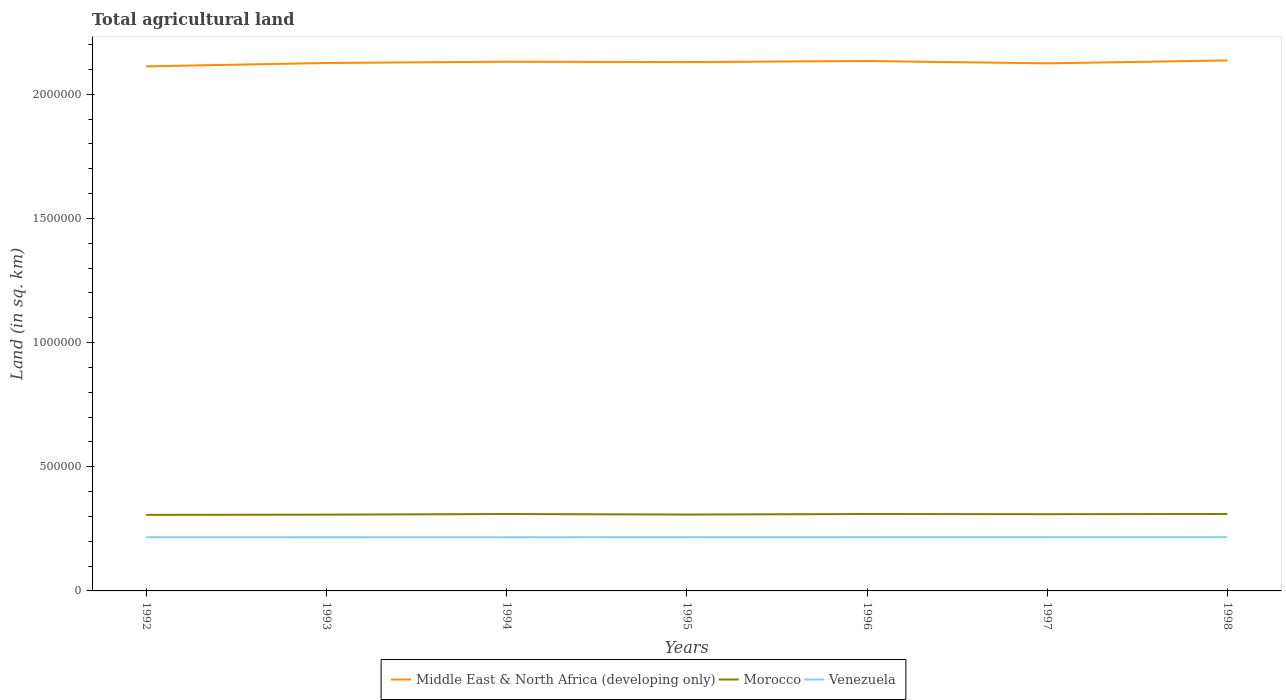How many different coloured lines are there?
Your response must be concise. 3. Across all years, what is the maximum total agricultural land in Venezuela?
Ensure brevity in your answer.  2.16e+05. What is the total total agricultural land in Morocco in the graph?
Give a very brief answer. -3600. What is the difference between the highest and the second highest total agricultural land in Venezuela?
Make the answer very short. 390. Does the graph contain any zero values?
Your answer should be compact. No. Does the graph contain grids?
Ensure brevity in your answer.  No. Where does the legend appear in the graph?
Give a very brief answer. Bottom center. What is the title of the graph?
Provide a succinct answer. Total agricultural land. What is the label or title of the X-axis?
Provide a succinct answer. Years. What is the label or title of the Y-axis?
Give a very brief answer. Land (in sq. km). What is the Land (in sq. km) in Middle East & North Africa (developing only) in 1992?
Provide a succinct answer. 2.11e+06. What is the Land (in sq. km) of Morocco in 1992?
Keep it short and to the point. 3.06e+05. What is the Land (in sq. km) in Venezuela in 1992?
Your answer should be very brief. 2.16e+05. What is the Land (in sq. km) in Middle East & North Africa (developing only) in 1993?
Offer a terse response. 2.13e+06. What is the Land (in sq. km) in Morocco in 1993?
Your response must be concise. 3.07e+05. What is the Land (in sq. km) in Venezuela in 1993?
Your answer should be compact. 2.16e+05. What is the Land (in sq. km) in Middle East & North Africa (developing only) in 1994?
Offer a very short reply. 2.13e+06. What is the Land (in sq. km) of Morocco in 1994?
Your answer should be very brief. 3.10e+05. What is the Land (in sq. km) of Venezuela in 1994?
Keep it short and to the point. 2.16e+05. What is the Land (in sq. km) in Middle East & North Africa (developing only) in 1995?
Give a very brief answer. 2.13e+06. What is the Land (in sq. km) in Morocco in 1995?
Your response must be concise. 3.07e+05. What is the Land (in sq. km) of Venezuela in 1995?
Offer a very short reply. 2.16e+05. What is the Land (in sq. km) in Middle East & North Africa (developing only) in 1996?
Your answer should be compact. 2.13e+06. What is the Land (in sq. km) in Morocco in 1996?
Your response must be concise. 3.10e+05. What is the Land (in sq. km) of Venezuela in 1996?
Make the answer very short. 2.16e+05. What is the Land (in sq. km) in Middle East & North Africa (developing only) in 1997?
Your answer should be compact. 2.12e+06. What is the Land (in sq. km) in Morocco in 1997?
Provide a short and direct response. 3.09e+05. What is the Land (in sq. km) in Venezuela in 1997?
Your response must be concise. 2.16e+05. What is the Land (in sq. km) of Middle East & North Africa (developing only) in 1998?
Make the answer very short. 2.14e+06. What is the Land (in sq. km) in Morocco in 1998?
Ensure brevity in your answer.  3.10e+05. What is the Land (in sq. km) of Venezuela in 1998?
Provide a short and direct response. 2.16e+05. Across all years, what is the maximum Land (in sq. km) of Middle East & North Africa (developing only)?
Provide a succinct answer. 2.14e+06. Across all years, what is the maximum Land (in sq. km) in Morocco?
Keep it short and to the point. 3.10e+05. Across all years, what is the maximum Land (in sq. km) of Venezuela?
Give a very brief answer. 2.16e+05. Across all years, what is the minimum Land (in sq. km) in Middle East & North Africa (developing only)?
Your answer should be very brief. 2.11e+06. Across all years, what is the minimum Land (in sq. km) in Morocco?
Keep it short and to the point. 3.06e+05. Across all years, what is the minimum Land (in sq. km) in Venezuela?
Provide a short and direct response. 2.16e+05. What is the total Land (in sq. km) of Middle East & North Africa (developing only) in the graph?
Provide a short and direct response. 1.49e+07. What is the total Land (in sq. km) of Morocco in the graph?
Offer a very short reply. 2.16e+06. What is the total Land (in sq. km) of Venezuela in the graph?
Your answer should be compact. 1.51e+06. What is the difference between the Land (in sq. km) of Middle East & North Africa (developing only) in 1992 and that in 1993?
Offer a very short reply. -1.37e+04. What is the difference between the Land (in sq. km) in Morocco in 1992 and that in 1993?
Your answer should be compact. -950. What is the difference between the Land (in sq. km) of Middle East & North Africa (developing only) in 1992 and that in 1994?
Provide a succinct answer. -1.89e+04. What is the difference between the Land (in sq. km) in Morocco in 1992 and that in 1994?
Offer a very short reply. -3480. What is the difference between the Land (in sq. km) of Middle East & North Africa (developing only) in 1992 and that in 1995?
Provide a short and direct response. -1.73e+04. What is the difference between the Land (in sq. km) of Morocco in 1992 and that in 1995?
Offer a terse response. -1330. What is the difference between the Land (in sq. km) in Venezuela in 1992 and that in 1995?
Keep it short and to the point. -130. What is the difference between the Land (in sq. km) of Middle East & North Africa (developing only) in 1992 and that in 1996?
Ensure brevity in your answer.  -2.17e+04. What is the difference between the Land (in sq. km) in Morocco in 1992 and that in 1996?
Ensure brevity in your answer.  -3500. What is the difference between the Land (in sq. km) of Venezuela in 1992 and that in 1996?
Ensure brevity in your answer.  -250. What is the difference between the Land (in sq. km) of Middle East & North Africa (developing only) in 1992 and that in 1997?
Your answer should be very brief. -1.22e+04. What is the difference between the Land (in sq. km) in Morocco in 1992 and that in 1997?
Give a very brief answer. -2790. What is the difference between the Land (in sq. km) of Venezuela in 1992 and that in 1997?
Offer a very short reply. -290. What is the difference between the Land (in sq. km) in Middle East & North Africa (developing only) in 1992 and that in 1998?
Provide a short and direct response. -2.40e+04. What is the difference between the Land (in sq. km) in Morocco in 1992 and that in 1998?
Give a very brief answer. -3600. What is the difference between the Land (in sq. km) in Venezuela in 1992 and that in 1998?
Ensure brevity in your answer.  -350. What is the difference between the Land (in sq. km) in Middle East & North Africa (developing only) in 1993 and that in 1994?
Offer a terse response. -5190. What is the difference between the Land (in sq. km) in Morocco in 1993 and that in 1994?
Provide a succinct answer. -2530. What is the difference between the Land (in sq. km) in Venezuela in 1993 and that in 1994?
Offer a terse response. -70. What is the difference between the Land (in sq. km) of Middle East & North Africa (developing only) in 1993 and that in 1995?
Ensure brevity in your answer.  -3650. What is the difference between the Land (in sq. km) in Morocco in 1993 and that in 1995?
Make the answer very short. -380. What is the difference between the Land (in sq. km) of Venezuela in 1993 and that in 1995?
Your answer should be very brief. -170. What is the difference between the Land (in sq. km) in Middle East & North Africa (developing only) in 1993 and that in 1996?
Provide a succinct answer. -8004.6. What is the difference between the Land (in sq. km) of Morocco in 1993 and that in 1996?
Offer a terse response. -2550. What is the difference between the Land (in sq. km) of Venezuela in 1993 and that in 1996?
Provide a succinct answer. -290. What is the difference between the Land (in sq. km) in Middle East & North Africa (developing only) in 1993 and that in 1997?
Provide a succinct answer. 1490.8. What is the difference between the Land (in sq. km) of Morocco in 1993 and that in 1997?
Your response must be concise. -1840. What is the difference between the Land (in sq. km) in Venezuela in 1993 and that in 1997?
Your answer should be very brief. -330. What is the difference between the Land (in sq. km) of Middle East & North Africa (developing only) in 1993 and that in 1998?
Your response must be concise. -1.03e+04. What is the difference between the Land (in sq. km) in Morocco in 1993 and that in 1998?
Ensure brevity in your answer.  -2650. What is the difference between the Land (in sq. km) in Venezuela in 1993 and that in 1998?
Provide a short and direct response. -390. What is the difference between the Land (in sq. km) in Middle East & North Africa (developing only) in 1994 and that in 1995?
Give a very brief answer. 1540. What is the difference between the Land (in sq. km) in Morocco in 1994 and that in 1995?
Your answer should be compact. 2150. What is the difference between the Land (in sq. km) in Venezuela in 1994 and that in 1995?
Offer a very short reply. -100. What is the difference between the Land (in sq. km) in Middle East & North Africa (developing only) in 1994 and that in 1996?
Make the answer very short. -2814.6. What is the difference between the Land (in sq. km) of Morocco in 1994 and that in 1996?
Provide a short and direct response. -20. What is the difference between the Land (in sq. km) in Venezuela in 1994 and that in 1996?
Provide a short and direct response. -220. What is the difference between the Land (in sq. km) in Middle East & North Africa (developing only) in 1994 and that in 1997?
Your answer should be compact. 6680.8. What is the difference between the Land (in sq. km) in Morocco in 1994 and that in 1997?
Offer a terse response. 690. What is the difference between the Land (in sq. km) of Venezuela in 1994 and that in 1997?
Make the answer very short. -260. What is the difference between the Land (in sq. km) in Middle East & North Africa (developing only) in 1994 and that in 1998?
Your answer should be compact. -5136.2. What is the difference between the Land (in sq. km) of Morocco in 1994 and that in 1998?
Give a very brief answer. -120. What is the difference between the Land (in sq. km) in Venezuela in 1994 and that in 1998?
Offer a terse response. -320. What is the difference between the Land (in sq. km) in Middle East & North Africa (developing only) in 1995 and that in 1996?
Offer a terse response. -4354.6. What is the difference between the Land (in sq. km) in Morocco in 1995 and that in 1996?
Offer a terse response. -2170. What is the difference between the Land (in sq. km) in Venezuela in 1995 and that in 1996?
Provide a succinct answer. -120. What is the difference between the Land (in sq. km) of Middle East & North Africa (developing only) in 1995 and that in 1997?
Offer a very short reply. 5140.8. What is the difference between the Land (in sq. km) of Morocco in 1995 and that in 1997?
Provide a short and direct response. -1460. What is the difference between the Land (in sq. km) in Venezuela in 1995 and that in 1997?
Offer a very short reply. -160. What is the difference between the Land (in sq. km) of Middle East & North Africa (developing only) in 1995 and that in 1998?
Keep it short and to the point. -6676.2. What is the difference between the Land (in sq. km) in Morocco in 1995 and that in 1998?
Offer a very short reply. -2270. What is the difference between the Land (in sq. km) in Venezuela in 1995 and that in 1998?
Your answer should be very brief. -220. What is the difference between the Land (in sq. km) in Middle East & North Africa (developing only) in 1996 and that in 1997?
Your answer should be very brief. 9495.4. What is the difference between the Land (in sq. km) in Morocco in 1996 and that in 1997?
Give a very brief answer. 710. What is the difference between the Land (in sq. km) of Venezuela in 1996 and that in 1997?
Your answer should be compact. -40. What is the difference between the Land (in sq. km) in Middle East & North Africa (developing only) in 1996 and that in 1998?
Ensure brevity in your answer.  -2321.6. What is the difference between the Land (in sq. km) in Morocco in 1996 and that in 1998?
Offer a very short reply. -100. What is the difference between the Land (in sq. km) of Venezuela in 1996 and that in 1998?
Offer a very short reply. -100. What is the difference between the Land (in sq. km) in Middle East & North Africa (developing only) in 1997 and that in 1998?
Your answer should be compact. -1.18e+04. What is the difference between the Land (in sq. km) of Morocco in 1997 and that in 1998?
Ensure brevity in your answer.  -810. What is the difference between the Land (in sq. km) in Venezuela in 1997 and that in 1998?
Keep it short and to the point. -60. What is the difference between the Land (in sq. km) of Middle East & North Africa (developing only) in 1992 and the Land (in sq. km) of Morocco in 1993?
Provide a succinct answer. 1.80e+06. What is the difference between the Land (in sq. km) in Middle East & North Africa (developing only) in 1992 and the Land (in sq. km) in Venezuela in 1993?
Keep it short and to the point. 1.90e+06. What is the difference between the Land (in sq. km) of Morocco in 1992 and the Land (in sq. km) of Venezuela in 1993?
Your answer should be compact. 9.01e+04. What is the difference between the Land (in sq. km) of Middle East & North Africa (developing only) in 1992 and the Land (in sq. km) of Morocco in 1994?
Your answer should be very brief. 1.80e+06. What is the difference between the Land (in sq. km) of Middle East & North Africa (developing only) in 1992 and the Land (in sq. km) of Venezuela in 1994?
Make the answer very short. 1.90e+06. What is the difference between the Land (in sq. km) in Morocco in 1992 and the Land (in sq. km) in Venezuela in 1994?
Make the answer very short. 9.01e+04. What is the difference between the Land (in sq. km) of Middle East & North Africa (developing only) in 1992 and the Land (in sq. km) of Morocco in 1995?
Give a very brief answer. 1.80e+06. What is the difference between the Land (in sq. km) in Middle East & North Africa (developing only) in 1992 and the Land (in sq. km) in Venezuela in 1995?
Offer a very short reply. 1.90e+06. What is the difference between the Land (in sq. km) in Morocco in 1992 and the Land (in sq. km) in Venezuela in 1995?
Ensure brevity in your answer.  9.00e+04. What is the difference between the Land (in sq. km) of Middle East & North Africa (developing only) in 1992 and the Land (in sq. km) of Morocco in 1996?
Your answer should be compact. 1.80e+06. What is the difference between the Land (in sq. km) of Middle East & North Africa (developing only) in 1992 and the Land (in sq. km) of Venezuela in 1996?
Provide a short and direct response. 1.90e+06. What is the difference between the Land (in sq. km) of Morocco in 1992 and the Land (in sq. km) of Venezuela in 1996?
Provide a succinct answer. 8.98e+04. What is the difference between the Land (in sq. km) in Middle East & North Africa (developing only) in 1992 and the Land (in sq. km) in Morocco in 1997?
Provide a succinct answer. 1.80e+06. What is the difference between the Land (in sq. km) of Middle East & North Africa (developing only) in 1992 and the Land (in sq. km) of Venezuela in 1997?
Provide a short and direct response. 1.90e+06. What is the difference between the Land (in sq. km) of Morocco in 1992 and the Land (in sq. km) of Venezuela in 1997?
Your answer should be compact. 8.98e+04. What is the difference between the Land (in sq. km) of Middle East & North Africa (developing only) in 1992 and the Land (in sq. km) of Morocco in 1998?
Give a very brief answer. 1.80e+06. What is the difference between the Land (in sq. km) of Middle East & North Africa (developing only) in 1992 and the Land (in sq. km) of Venezuela in 1998?
Keep it short and to the point. 1.90e+06. What is the difference between the Land (in sq. km) of Morocco in 1992 and the Land (in sq. km) of Venezuela in 1998?
Your answer should be compact. 8.97e+04. What is the difference between the Land (in sq. km) of Middle East & North Africa (developing only) in 1993 and the Land (in sq. km) of Morocco in 1994?
Your answer should be compact. 1.82e+06. What is the difference between the Land (in sq. km) in Middle East & North Africa (developing only) in 1993 and the Land (in sq. km) in Venezuela in 1994?
Provide a short and direct response. 1.91e+06. What is the difference between the Land (in sq. km) of Morocco in 1993 and the Land (in sq. km) of Venezuela in 1994?
Offer a very short reply. 9.10e+04. What is the difference between the Land (in sq. km) in Middle East & North Africa (developing only) in 1993 and the Land (in sq. km) in Morocco in 1995?
Give a very brief answer. 1.82e+06. What is the difference between the Land (in sq. km) of Middle East & North Africa (developing only) in 1993 and the Land (in sq. km) of Venezuela in 1995?
Your answer should be very brief. 1.91e+06. What is the difference between the Land (in sq. km) in Morocco in 1993 and the Land (in sq. km) in Venezuela in 1995?
Provide a succinct answer. 9.09e+04. What is the difference between the Land (in sq. km) in Middle East & North Africa (developing only) in 1993 and the Land (in sq. km) in Morocco in 1996?
Keep it short and to the point. 1.82e+06. What is the difference between the Land (in sq. km) of Middle East & North Africa (developing only) in 1993 and the Land (in sq. km) of Venezuela in 1996?
Your response must be concise. 1.91e+06. What is the difference between the Land (in sq. km) of Morocco in 1993 and the Land (in sq. km) of Venezuela in 1996?
Ensure brevity in your answer.  9.08e+04. What is the difference between the Land (in sq. km) of Middle East & North Africa (developing only) in 1993 and the Land (in sq. km) of Morocco in 1997?
Keep it short and to the point. 1.82e+06. What is the difference between the Land (in sq. km) in Middle East & North Africa (developing only) in 1993 and the Land (in sq. km) in Venezuela in 1997?
Your answer should be compact. 1.91e+06. What is the difference between the Land (in sq. km) of Morocco in 1993 and the Land (in sq. km) of Venezuela in 1997?
Your answer should be compact. 9.08e+04. What is the difference between the Land (in sq. km) of Middle East & North Africa (developing only) in 1993 and the Land (in sq. km) of Morocco in 1998?
Your response must be concise. 1.82e+06. What is the difference between the Land (in sq. km) in Middle East & North Africa (developing only) in 1993 and the Land (in sq. km) in Venezuela in 1998?
Give a very brief answer. 1.91e+06. What is the difference between the Land (in sq. km) of Morocco in 1993 and the Land (in sq. km) of Venezuela in 1998?
Your answer should be compact. 9.07e+04. What is the difference between the Land (in sq. km) of Middle East & North Africa (developing only) in 1994 and the Land (in sq. km) of Morocco in 1995?
Offer a very short reply. 1.82e+06. What is the difference between the Land (in sq. km) in Middle East & North Africa (developing only) in 1994 and the Land (in sq. km) in Venezuela in 1995?
Give a very brief answer. 1.91e+06. What is the difference between the Land (in sq. km) of Morocco in 1994 and the Land (in sq. km) of Venezuela in 1995?
Offer a very short reply. 9.34e+04. What is the difference between the Land (in sq. km) in Middle East & North Africa (developing only) in 1994 and the Land (in sq. km) in Morocco in 1996?
Give a very brief answer. 1.82e+06. What is the difference between the Land (in sq. km) of Middle East & North Africa (developing only) in 1994 and the Land (in sq. km) of Venezuela in 1996?
Your answer should be very brief. 1.91e+06. What is the difference between the Land (in sq. km) in Morocco in 1994 and the Land (in sq. km) in Venezuela in 1996?
Your answer should be very brief. 9.33e+04. What is the difference between the Land (in sq. km) of Middle East & North Africa (developing only) in 1994 and the Land (in sq. km) of Morocco in 1997?
Provide a short and direct response. 1.82e+06. What is the difference between the Land (in sq. km) of Middle East & North Africa (developing only) in 1994 and the Land (in sq. km) of Venezuela in 1997?
Ensure brevity in your answer.  1.91e+06. What is the difference between the Land (in sq. km) of Morocco in 1994 and the Land (in sq. km) of Venezuela in 1997?
Keep it short and to the point. 9.33e+04. What is the difference between the Land (in sq. km) in Middle East & North Africa (developing only) in 1994 and the Land (in sq. km) in Morocco in 1998?
Make the answer very short. 1.82e+06. What is the difference between the Land (in sq. km) in Middle East & North Africa (developing only) in 1994 and the Land (in sq. km) in Venezuela in 1998?
Give a very brief answer. 1.91e+06. What is the difference between the Land (in sq. km) in Morocco in 1994 and the Land (in sq. km) in Venezuela in 1998?
Your answer should be compact. 9.32e+04. What is the difference between the Land (in sq. km) of Middle East & North Africa (developing only) in 1995 and the Land (in sq. km) of Morocco in 1996?
Your answer should be very brief. 1.82e+06. What is the difference between the Land (in sq. km) of Middle East & North Africa (developing only) in 1995 and the Land (in sq. km) of Venezuela in 1996?
Keep it short and to the point. 1.91e+06. What is the difference between the Land (in sq. km) of Morocco in 1995 and the Land (in sq. km) of Venezuela in 1996?
Ensure brevity in your answer.  9.12e+04. What is the difference between the Land (in sq. km) of Middle East & North Africa (developing only) in 1995 and the Land (in sq. km) of Morocco in 1997?
Give a very brief answer. 1.82e+06. What is the difference between the Land (in sq. km) of Middle East & North Africa (developing only) in 1995 and the Land (in sq. km) of Venezuela in 1997?
Make the answer very short. 1.91e+06. What is the difference between the Land (in sq. km) of Morocco in 1995 and the Land (in sq. km) of Venezuela in 1997?
Your answer should be very brief. 9.11e+04. What is the difference between the Land (in sq. km) in Middle East & North Africa (developing only) in 1995 and the Land (in sq. km) in Morocco in 1998?
Your response must be concise. 1.82e+06. What is the difference between the Land (in sq. km) of Middle East & North Africa (developing only) in 1995 and the Land (in sq. km) of Venezuela in 1998?
Provide a short and direct response. 1.91e+06. What is the difference between the Land (in sq. km) in Morocco in 1995 and the Land (in sq. km) in Venezuela in 1998?
Keep it short and to the point. 9.11e+04. What is the difference between the Land (in sq. km) in Middle East & North Africa (developing only) in 1996 and the Land (in sq. km) in Morocco in 1997?
Make the answer very short. 1.82e+06. What is the difference between the Land (in sq. km) of Middle East & North Africa (developing only) in 1996 and the Land (in sq. km) of Venezuela in 1997?
Provide a short and direct response. 1.92e+06. What is the difference between the Land (in sq. km) in Morocco in 1996 and the Land (in sq. km) in Venezuela in 1997?
Ensure brevity in your answer.  9.33e+04. What is the difference between the Land (in sq. km) of Middle East & North Africa (developing only) in 1996 and the Land (in sq. km) of Morocco in 1998?
Give a very brief answer. 1.82e+06. What is the difference between the Land (in sq. km) in Middle East & North Africa (developing only) in 1996 and the Land (in sq. km) in Venezuela in 1998?
Give a very brief answer. 1.92e+06. What is the difference between the Land (in sq. km) of Morocco in 1996 and the Land (in sq. km) of Venezuela in 1998?
Your answer should be compact. 9.32e+04. What is the difference between the Land (in sq. km) of Middle East & North Africa (developing only) in 1997 and the Land (in sq. km) of Morocco in 1998?
Your answer should be compact. 1.81e+06. What is the difference between the Land (in sq. km) in Middle East & North Africa (developing only) in 1997 and the Land (in sq. km) in Venezuela in 1998?
Give a very brief answer. 1.91e+06. What is the difference between the Land (in sq. km) of Morocco in 1997 and the Land (in sq. km) of Venezuela in 1998?
Provide a succinct answer. 9.25e+04. What is the average Land (in sq. km) of Middle East & North Africa (developing only) per year?
Ensure brevity in your answer.  2.13e+06. What is the average Land (in sq. km) in Morocco per year?
Provide a succinct answer. 3.08e+05. What is the average Land (in sq. km) of Venezuela per year?
Your answer should be very brief. 2.16e+05. In the year 1992, what is the difference between the Land (in sq. km) in Middle East & North Africa (developing only) and Land (in sq. km) in Morocco?
Ensure brevity in your answer.  1.81e+06. In the year 1992, what is the difference between the Land (in sq. km) of Middle East & North Africa (developing only) and Land (in sq. km) of Venezuela?
Make the answer very short. 1.90e+06. In the year 1992, what is the difference between the Land (in sq. km) in Morocco and Land (in sq. km) in Venezuela?
Provide a short and direct response. 9.01e+04. In the year 1993, what is the difference between the Land (in sq. km) of Middle East & North Africa (developing only) and Land (in sq. km) of Morocco?
Give a very brief answer. 1.82e+06. In the year 1993, what is the difference between the Land (in sq. km) in Middle East & North Africa (developing only) and Land (in sq. km) in Venezuela?
Your answer should be very brief. 1.91e+06. In the year 1993, what is the difference between the Land (in sq. km) of Morocco and Land (in sq. km) of Venezuela?
Offer a terse response. 9.11e+04. In the year 1994, what is the difference between the Land (in sq. km) of Middle East & North Africa (developing only) and Land (in sq. km) of Morocco?
Offer a terse response. 1.82e+06. In the year 1994, what is the difference between the Land (in sq. km) in Middle East & North Africa (developing only) and Land (in sq. km) in Venezuela?
Keep it short and to the point. 1.91e+06. In the year 1994, what is the difference between the Land (in sq. km) in Morocco and Land (in sq. km) in Venezuela?
Provide a succinct answer. 9.35e+04. In the year 1995, what is the difference between the Land (in sq. km) in Middle East & North Africa (developing only) and Land (in sq. km) in Morocco?
Offer a very short reply. 1.82e+06. In the year 1995, what is the difference between the Land (in sq. km) in Middle East & North Africa (developing only) and Land (in sq. km) in Venezuela?
Your response must be concise. 1.91e+06. In the year 1995, what is the difference between the Land (in sq. km) in Morocco and Land (in sq. km) in Venezuela?
Give a very brief answer. 9.13e+04. In the year 1996, what is the difference between the Land (in sq. km) of Middle East & North Africa (developing only) and Land (in sq. km) of Morocco?
Your response must be concise. 1.82e+06. In the year 1996, what is the difference between the Land (in sq. km) in Middle East & North Africa (developing only) and Land (in sq. km) in Venezuela?
Offer a terse response. 1.92e+06. In the year 1996, what is the difference between the Land (in sq. km) in Morocco and Land (in sq. km) in Venezuela?
Provide a short and direct response. 9.33e+04. In the year 1997, what is the difference between the Land (in sq. km) of Middle East & North Africa (developing only) and Land (in sq. km) of Morocco?
Your answer should be very brief. 1.82e+06. In the year 1997, what is the difference between the Land (in sq. km) of Middle East & North Africa (developing only) and Land (in sq. km) of Venezuela?
Offer a terse response. 1.91e+06. In the year 1997, what is the difference between the Land (in sq. km) in Morocco and Land (in sq. km) in Venezuela?
Provide a short and direct response. 9.26e+04. In the year 1998, what is the difference between the Land (in sq. km) of Middle East & North Africa (developing only) and Land (in sq. km) of Morocco?
Offer a very short reply. 1.83e+06. In the year 1998, what is the difference between the Land (in sq. km) of Middle East & North Africa (developing only) and Land (in sq. km) of Venezuela?
Ensure brevity in your answer.  1.92e+06. In the year 1998, what is the difference between the Land (in sq. km) of Morocco and Land (in sq. km) of Venezuela?
Offer a very short reply. 9.33e+04. What is the ratio of the Land (in sq. km) of Middle East & North Africa (developing only) in 1992 to that in 1993?
Your answer should be very brief. 0.99. What is the ratio of the Land (in sq. km) in Morocco in 1992 to that in 1993?
Provide a short and direct response. 1. What is the ratio of the Land (in sq. km) in Venezuela in 1992 to that in 1993?
Provide a succinct answer. 1. What is the ratio of the Land (in sq. km) of Middle East & North Africa (developing only) in 1992 to that in 1994?
Ensure brevity in your answer.  0.99. What is the ratio of the Land (in sq. km) in Morocco in 1992 to that in 1994?
Offer a very short reply. 0.99. What is the ratio of the Land (in sq. km) in Middle East & North Africa (developing only) in 1992 to that in 1995?
Offer a very short reply. 0.99. What is the ratio of the Land (in sq. km) of Venezuela in 1992 to that in 1995?
Your response must be concise. 1. What is the ratio of the Land (in sq. km) of Middle East & North Africa (developing only) in 1992 to that in 1996?
Provide a short and direct response. 0.99. What is the ratio of the Land (in sq. km) in Morocco in 1992 to that in 1996?
Make the answer very short. 0.99. What is the ratio of the Land (in sq. km) of Venezuela in 1992 to that in 1997?
Ensure brevity in your answer.  1. What is the ratio of the Land (in sq. km) in Morocco in 1992 to that in 1998?
Provide a succinct answer. 0.99. What is the ratio of the Land (in sq. km) in Venezuela in 1992 to that in 1998?
Provide a short and direct response. 1. What is the ratio of the Land (in sq. km) of Middle East & North Africa (developing only) in 1993 to that in 1994?
Your response must be concise. 1. What is the ratio of the Land (in sq. km) of Venezuela in 1993 to that in 1994?
Give a very brief answer. 1. What is the ratio of the Land (in sq. km) in Venezuela in 1993 to that in 1995?
Give a very brief answer. 1. What is the ratio of the Land (in sq. km) of Middle East & North Africa (developing only) in 1993 to that in 1996?
Offer a very short reply. 1. What is the ratio of the Land (in sq. km) in Venezuela in 1993 to that in 1996?
Offer a very short reply. 1. What is the ratio of the Land (in sq. km) in Venezuela in 1993 to that in 1997?
Provide a succinct answer. 1. What is the ratio of the Land (in sq. km) of Middle East & North Africa (developing only) in 1993 to that in 1998?
Make the answer very short. 1. What is the ratio of the Land (in sq. km) of Venezuela in 1993 to that in 1998?
Ensure brevity in your answer.  1. What is the ratio of the Land (in sq. km) in Middle East & North Africa (developing only) in 1994 to that in 1995?
Offer a very short reply. 1. What is the ratio of the Land (in sq. km) of Morocco in 1994 to that in 1996?
Offer a very short reply. 1. What is the ratio of the Land (in sq. km) in Venezuela in 1994 to that in 1996?
Offer a terse response. 1. What is the ratio of the Land (in sq. km) of Morocco in 1994 to that in 1997?
Your answer should be very brief. 1. What is the ratio of the Land (in sq. km) in Middle East & North Africa (developing only) in 1994 to that in 1998?
Keep it short and to the point. 1. What is the ratio of the Land (in sq. km) in Venezuela in 1995 to that in 1996?
Offer a terse response. 1. What is the ratio of the Land (in sq. km) of Middle East & North Africa (developing only) in 1995 to that in 1997?
Make the answer very short. 1. What is the ratio of the Land (in sq. km) in Morocco in 1995 to that in 1997?
Provide a succinct answer. 1. What is the ratio of the Land (in sq. km) in Middle East & North Africa (developing only) in 1995 to that in 1998?
Make the answer very short. 1. What is the ratio of the Land (in sq. km) of Venezuela in 1996 to that in 1997?
Provide a short and direct response. 1. What is the ratio of the Land (in sq. km) of Venezuela in 1996 to that in 1998?
Make the answer very short. 1. What is the ratio of the Land (in sq. km) of Morocco in 1997 to that in 1998?
Your answer should be compact. 1. What is the ratio of the Land (in sq. km) in Venezuela in 1997 to that in 1998?
Offer a very short reply. 1. What is the difference between the highest and the second highest Land (in sq. km) in Middle East & North Africa (developing only)?
Provide a short and direct response. 2321.6. What is the difference between the highest and the second highest Land (in sq. km) in Morocco?
Provide a succinct answer. 100. What is the difference between the highest and the lowest Land (in sq. km) in Middle East & North Africa (developing only)?
Give a very brief answer. 2.40e+04. What is the difference between the highest and the lowest Land (in sq. km) of Morocco?
Your response must be concise. 3600. What is the difference between the highest and the lowest Land (in sq. km) in Venezuela?
Give a very brief answer. 390. 